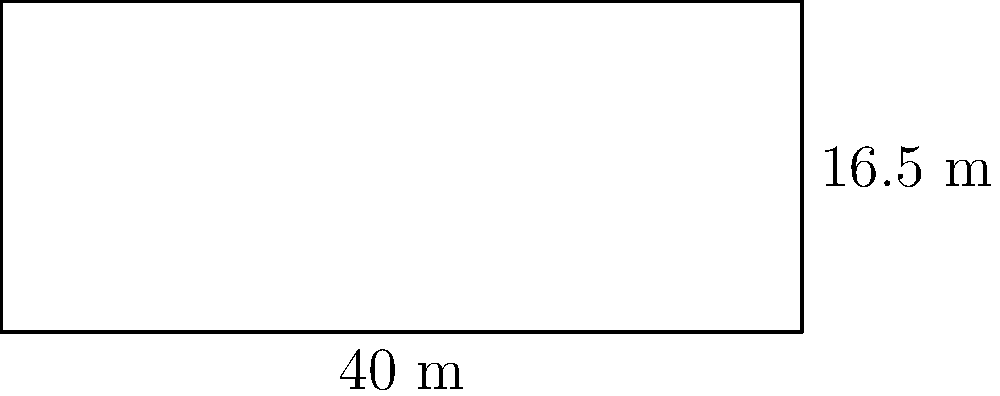In a football match at Kasarani Stadium, you notice the referee measuring the penalty box. If the penalty box is rectangular with a width of 40 meters and a length of 16.5 meters, what is its area in square meters? To find the area of the rectangular penalty box, we need to multiply its width by its length. Let's break it down step-by-step:

1. Identify the given dimensions:
   - Width of the penalty box = 40 meters
   - Length of the penalty box = 16.5 meters

2. Use the formula for the area of a rectangle:
   Area = width × length

3. Substitute the values into the formula:
   Area = 40 m × 16.5 m

4. Perform the multiplication:
   Area = 660 m²

Therefore, the area of the penalty box is 660 square meters.
Answer: 660 m² 